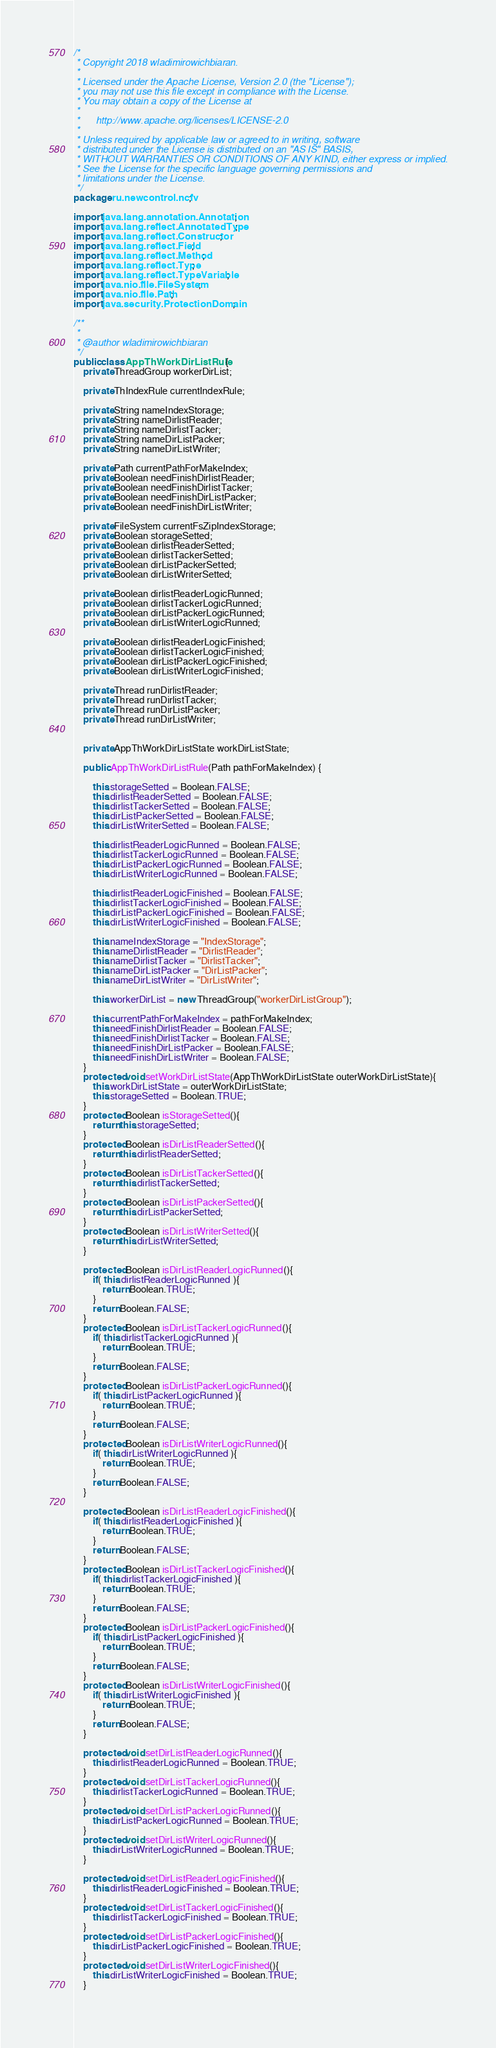<code> <loc_0><loc_0><loc_500><loc_500><_Java_>/*
 * Copyright 2018 wladimirowichbiaran.
 *
 * Licensed under the Apache License, Version 2.0 (the "License");
 * you may not use this file except in compliance with the License.
 * You may obtain a copy of the License at
 *
 *      http://www.apache.org/licenses/LICENSE-2.0
 *
 * Unless required by applicable law or agreed to in writing, software
 * distributed under the License is distributed on an "AS IS" BASIS,
 * WITHOUT WARRANTIES OR CONDITIONS OF ANY KIND, either express or implied.
 * See the License for the specific language governing permissions and
 * limitations under the License.
 */
package ru.newcontrol.ncfv;

import java.lang.annotation.Annotation;
import java.lang.reflect.AnnotatedType;
import java.lang.reflect.Constructor;
import java.lang.reflect.Field;
import java.lang.reflect.Method;
import java.lang.reflect.Type;
import java.lang.reflect.TypeVariable;
import java.nio.file.FileSystem;
import java.nio.file.Path;
import java.security.ProtectionDomain;

/**
 *
 * @author wladimirowichbiaran
 */
public class AppThWorkDirListRule {
    private ThreadGroup workerDirList;
    
    private ThIndexRule currentIndexRule;
    
    private String nameIndexStorage;
    private String nameDirlistReader;
    private String nameDirlistTacker;
    private String nameDirListPacker;
    private String nameDirListWriter;
    
    private Path currentPathForMakeIndex;
    private Boolean needFinishDirlistReader;
    private Boolean needFinishDirlistTacker;
    private Boolean needFinishDirListPacker;
    private Boolean needFinishDirListWriter;
    
    private FileSystem currentFsZipIndexStorage;
    private Boolean storageSetted;
    private Boolean dirlistReaderSetted;
    private Boolean dirlistTackerSetted;
    private Boolean dirListPackerSetted;
    private Boolean dirListWriterSetted;
    
    private Boolean dirlistReaderLogicRunned;
    private Boolean dirlistTackerLogicRunned;
    private Boolean dirListPackerLogicRunned;
    private Boolean dirListWriterLogicRunned;
    
    private Boolean dirlistReaderLogicFinished;
    private Boolean dirlistTackerLogicFinished;
    private Boolean dirListPackerLogicFinished;
    private Boolean dirListWriterLogicFinished;
    
    private Thread runDirlistReader;
    private Thread runDirlistTacker;
    private Thread runDirListPacker;
    private Thread runDirListWriter;
    
    
    private AppThWorkDirListState workDirListState;

    public AppThWorkDirListRule(Path pathForMakeIndex) {
        
        this.storageSetted = Boolean.FALSE;
        this.dirlistReaderSetted = Boolean.FALSE;
        this.dirlistTackerSetted = Boolean.FALSE;
        this.dirListPackerSetted = Boolean.FALSE;
        this.dirListWriterSetted = Boolean.FALSE;
        
        this.dirlistReaderLogicRunned = Boolean.FALSE;
        this.dirlistTackerLogicRunned = Boolean.FALSE;
        this.dirListPackerLogicRunned = Boolean.FALSE;
        this.dirListWriterLogicRunned = Boolean.FALSE;
        
        this.dirlistReaderLogicFinished = Boolean.FALSE;
        this.dirlistTackerLogicFinished = Boolean.FALSE;
        this.dirListPackerLogicFinished = Boolean.FALSE;
        this.dirListWriterLogicFinished = Boolean.FALSE;
        
        this.nameIndexStorage = "IndexStorage";
        this.nameDirlistReader = "DirlistReader";
        this.nameDirlistTacker = "DirlistTacker";
        this.nameDirListPacker = "DirListPacker";
        this.nameDirListWriter = "DirListWriter";
        
        this.workerDirList = new ThreadGroup("workerDirListGroup");
        
        this.currentPathForMakeIndex = pathForMakeIndex;
        this.needFinishDirlistReader = Boolean.FALSE;
        this.needFinishDirlistTacker = Boolean.FALSE;
        this.needFinishDirListPacker = Boolean.FALSE;
        this.needFinishDirListWriter = Boolean.FALSE;
    }
    protected void setWorkDirListState(AppThWorkDirListState outerWorkDirListState){
        this.workDirListState = outerWorkDirListState;
        this.storageSetted = Boolean.TRUE;
    }
    protected Boolean isStorageSetted(){
        return this.storageSetted;
    }
    protected Boolean isDirListReaderSetted(){
        return this.dirlistReaderSetted;
    }
    protected Boolean isDirListTackerSetted(){
        return this.dirlistTackerSetted;
    }
    protected Boolean isDirListPackerSetted(){
        return this.dirListPackerSetted;
    }
    protected Boolean isDirListWriterSetted(){
        return this.dirListWriterSetted;
    }
    
    protected Boolean isDirListReaderLogicRunned(){
        if( this.dirlistReaderLogicRunned ){
            return Boolean.TRUE;
        }
        return Boolean.FALSE;
    }
    protected Boolean isDirListTackerLogicRunned(){
        if( this.dirlistTackerLogicRunned ){
            return Boolean.TRUE;
        }
        return Boolean.FALSE;
    }
    protected Boolean isDirListPackerLogicRunned(){
        if( this.dirListPackerLogicRunned ){
            return Boolean.TRUE;
        }
        return Boolean.FALSE;
    }
    protected Boolean isDirListWriterLogicRunned(){
        if( this.dirListWriterLogicRunned ){
            return Boolean.TRUE;
        }
        return Boolean.FALSE;
    }
    
    protected Boolean isDirListReaderLogicFinished(){
        if( this.dirlistReaderLogicFinished ){
            return Boolean.TRUE;
        }
        return Boolean.FALSE;
    }
    protected Boolean isDirListTackerLogicFinished(){
        if( this.dirlistTackerLogicFinished ){
            return Boolean.TRUE;
        }
        return Boolean.FALSE;
    }
    protected Boolean isDirListPackerLogicFinished(){
        if( this.dirListPackerLogicFinished ){
            return Boolean.TRUE;
        }
        return Boolean.FALSE;
    }
    protected Boolean isDirListWriterLogicFinished(){
        if( this.dirListWriterLogicFinished ){
            return Boolean.TRUE;
        }
        return Boolean.FALSE;
    }
    
    protected void setDirListReaderLogicRunned(){
        this.dirlistReaderLogicRunned = Boolean.TRUE;
    }
    protected void setDirListTackerLogicRunned(){
        this.dirlistTackerLogicRunned = Boolean.TRUE;
    }
    protected void setDirListPackerLogicRunned(){
        this.dirListPackerLogicRunned = Boolean.TRUE;
    }
    protected void setDirListWriterLogicRunned(){
        this.dirListWriterLogicRunned = Boolean.TRUE;
    }
    
    protected void setDirListReaderLogicFinished(){
        this.dirlistReaderLogicFinished = Boolean.TRUE;
    }
    protected void setDirListTackerLogicFinished(){
        this.dirlistTackerLogicFinished = Boolean.TRUE;
    }
    protected void setDirListPackerLogicFinished(){
        this.dirListPackerLogicFinished = Boolean.TRUE;
    }
    protected void setDirListWriterLogicFinished(){
        this.dirListWriterLogicFinished = Boolean.TRUE;
    }
    </code> 